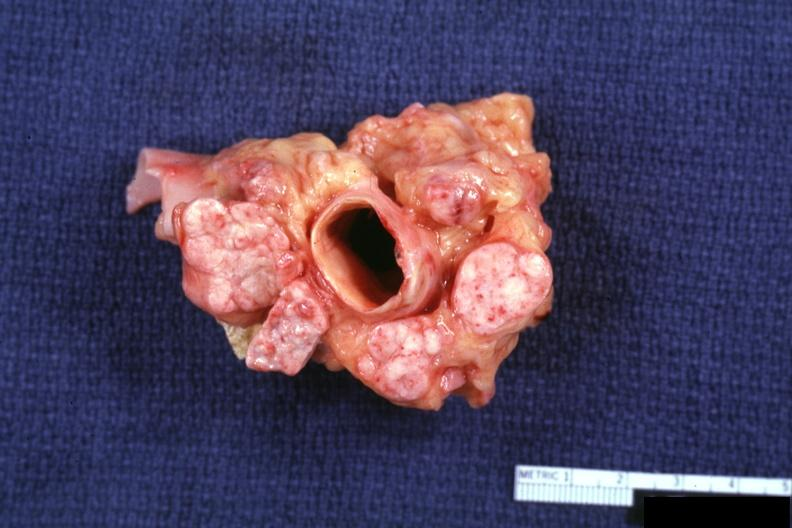what is present?
Answer the question using a single word or phrase. Metastatic carcinoma prostate 